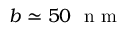<formula> <loc_0><loc_0><loc_500><loc_500>b \simeq 5 0 \ n m</formula> 